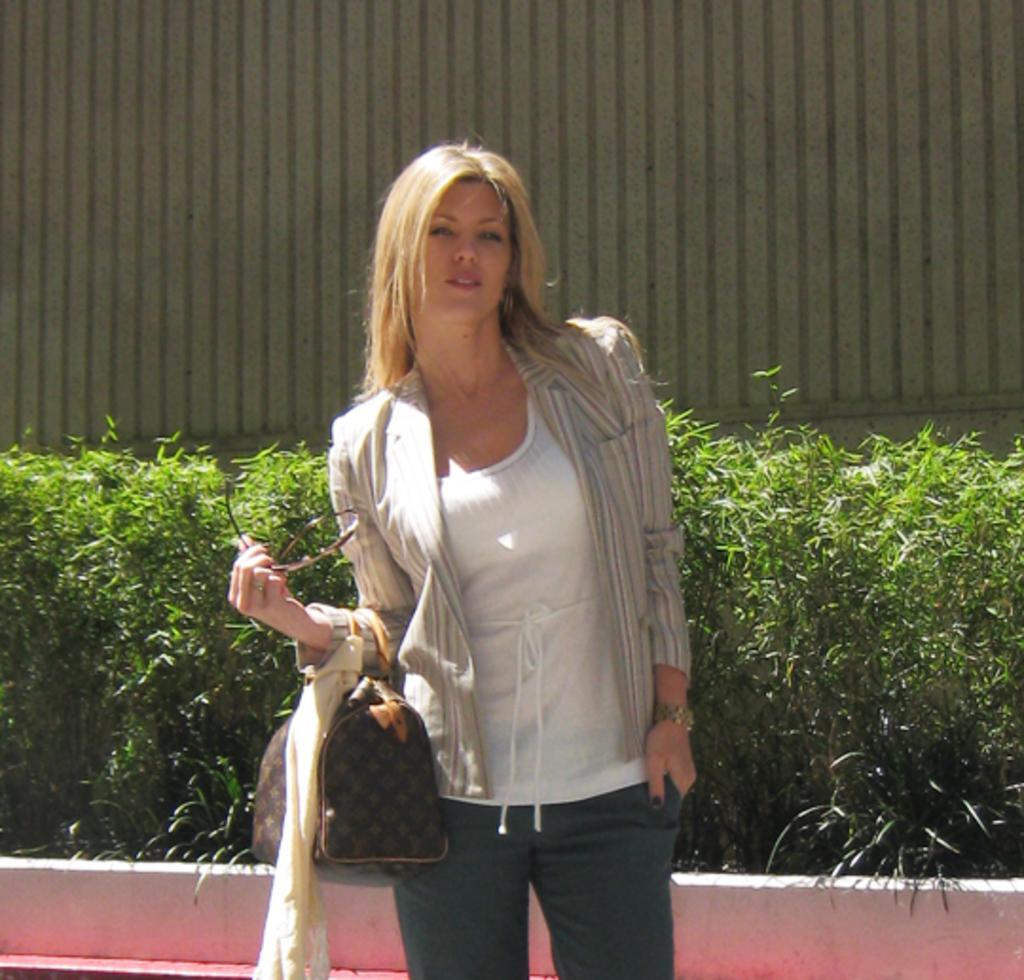How would you summarize this image in a sentence or two? A woman is standing with a handbag behind her there are bushes. Behind that there is a wall. 